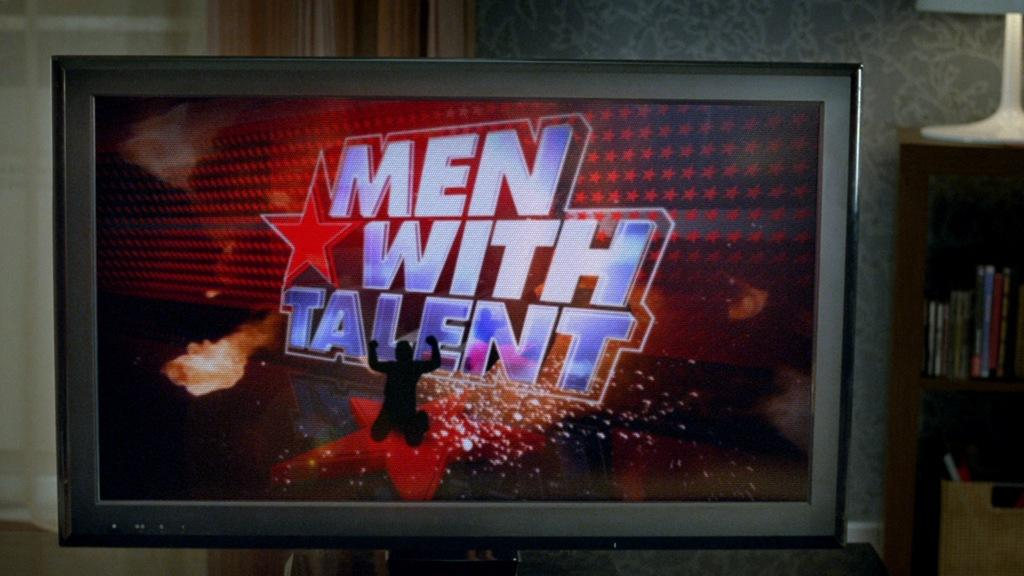<image>
Provide a brief description of the given image. a television that says men with talent on it 